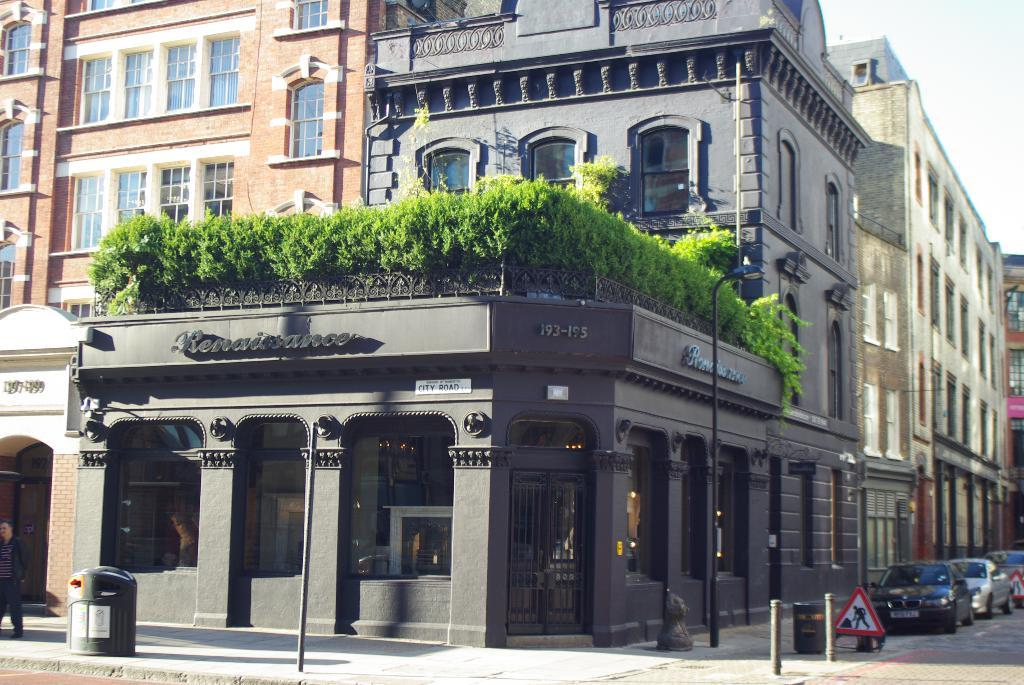What is located in the center of the picture? There are buildings and plants in the center of the picture. What can be seen in the foreground of the image? There are poles, dustbins, a signboard, and cars in the foreground of the image. What is the weather like in the image? The sky is sunny in the image. What type of education is being taught in the copy machine in the image? There is no copy machine or any indication of education in the image. 